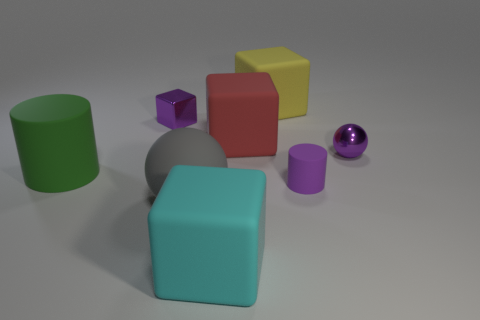What number of other objects are there of the same material as the large cylinder?
Your response must be concise. 5. How many tiny objects are either purple rubber blocks or yellow blocks?
Make the answer very short. 0. Are there an equal number of gray things that are behind the green matte cylinder and purple metal blocks?
Offer a terse response. No. There is a small thing on the left side of the cyan matte thing; are there any small shiny things to the left of it?
Offer a very short reply. No. What number of other things are there of the same color as the tiny shiny cube?
Your answer should be compact. 2. What is the color of the big cylinder?
Your answer should be compact. Green. How big is the purple thing that is both to the left of the small ball and behind the purple rubber cylinder?
Offer a terse response. Small. How many objects are purple metal things that are right of the yellow rubber object or balls?
Keep it short and to the point. 2. The purple object that is made of the same material as the big yellow object is what shape?
Offer a very short reply. Cylinder. The big cyan thing has what shape?
Your response must be concise. Cube. 